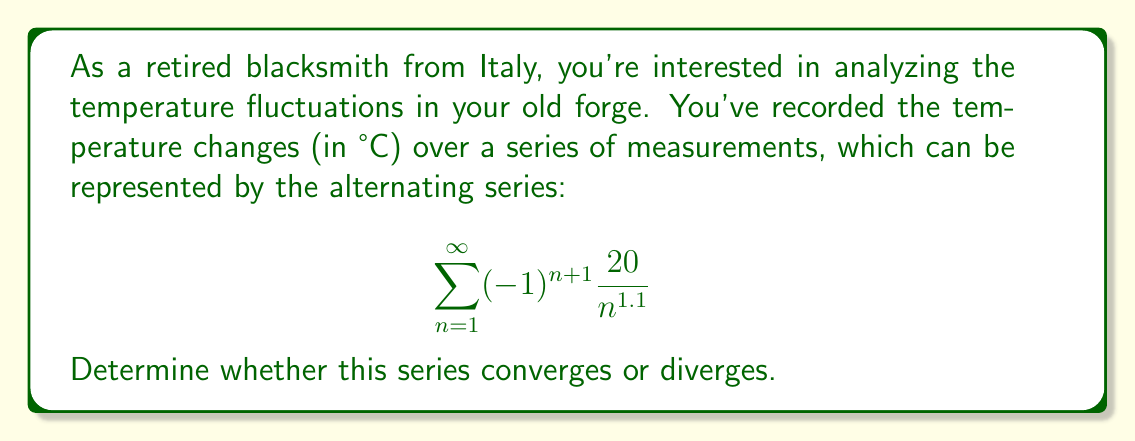Give your solution to this math problem. To determine the convergence of this alternating series, we can use the Alternating Series Test. The test states that for an alternating series of the form $\sum_{n=1}^{\infty} (-1)^{n+1} a_n$ or $\sum_{n=1}^{\infty} (-1)^n a_n$, where $a_n > 0$ for all $n$, the series converges if:

1. $\lim_{n \to \infty} a_n = 0$
2. The sequence $\{a_n\}$ is decreasing for all $n \geq N$, for some positive integer $N$.

Let's check these conditions for our series:

1. $a_n = \frac{20}{n^{1.1}}$

First, let's check the limit:

$$ \lim_{n \to \infty} a_n = \lim_{n \to \infty} \frac{20}{n^{1.1}} = 0 $$

This satisfies the first condition.

2. To check if the sequence is decreasing, we can compare $a_n$ and $a_{n+1}$:

$$ a_n = \frac{20}{n^{1.1}} \quad \text{and} \quad a_{n+1} = \frac{20}{(n+1)^{1.1}} $$

For the sequence to be decreasing, we need $a_n > a_{n+1}$ for all $n \geq N$:

$$ \frac{20}{n^{1.1}} > \frac{20}{(n+1)^{1.1}} $$

This inequality holds for all $n \geq 1$ because $n < n+1$.

Since both conditions of the Alternating Series Test are satisfied, we can conclude that the series converges.

Additionally, we can note that this is a p-series with $p = 1.1 > 1$, which means that even the series of absolute values $\sum_{n=1}^{\infty} \frac{20}{n^{1.1}}$ converges. This implies that our alternating series is absolutely convergent.
Answer: The alternating series $\sum_{n=1}^{\infty} (-1)^{n+1} \frac{20}{n^{1.1}}$ converges. 